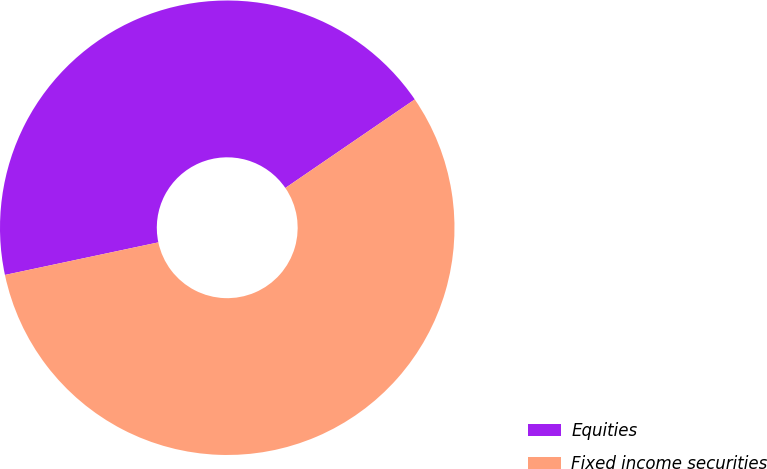Convert chart to OTSL. <chart><loc_0><loc_0><loc_500><loc_500><pie_chart><fcel>Equities<fcel>Fixed income securities<nl><fcel>43.78%<fcel>56.22%<nl></chart> 